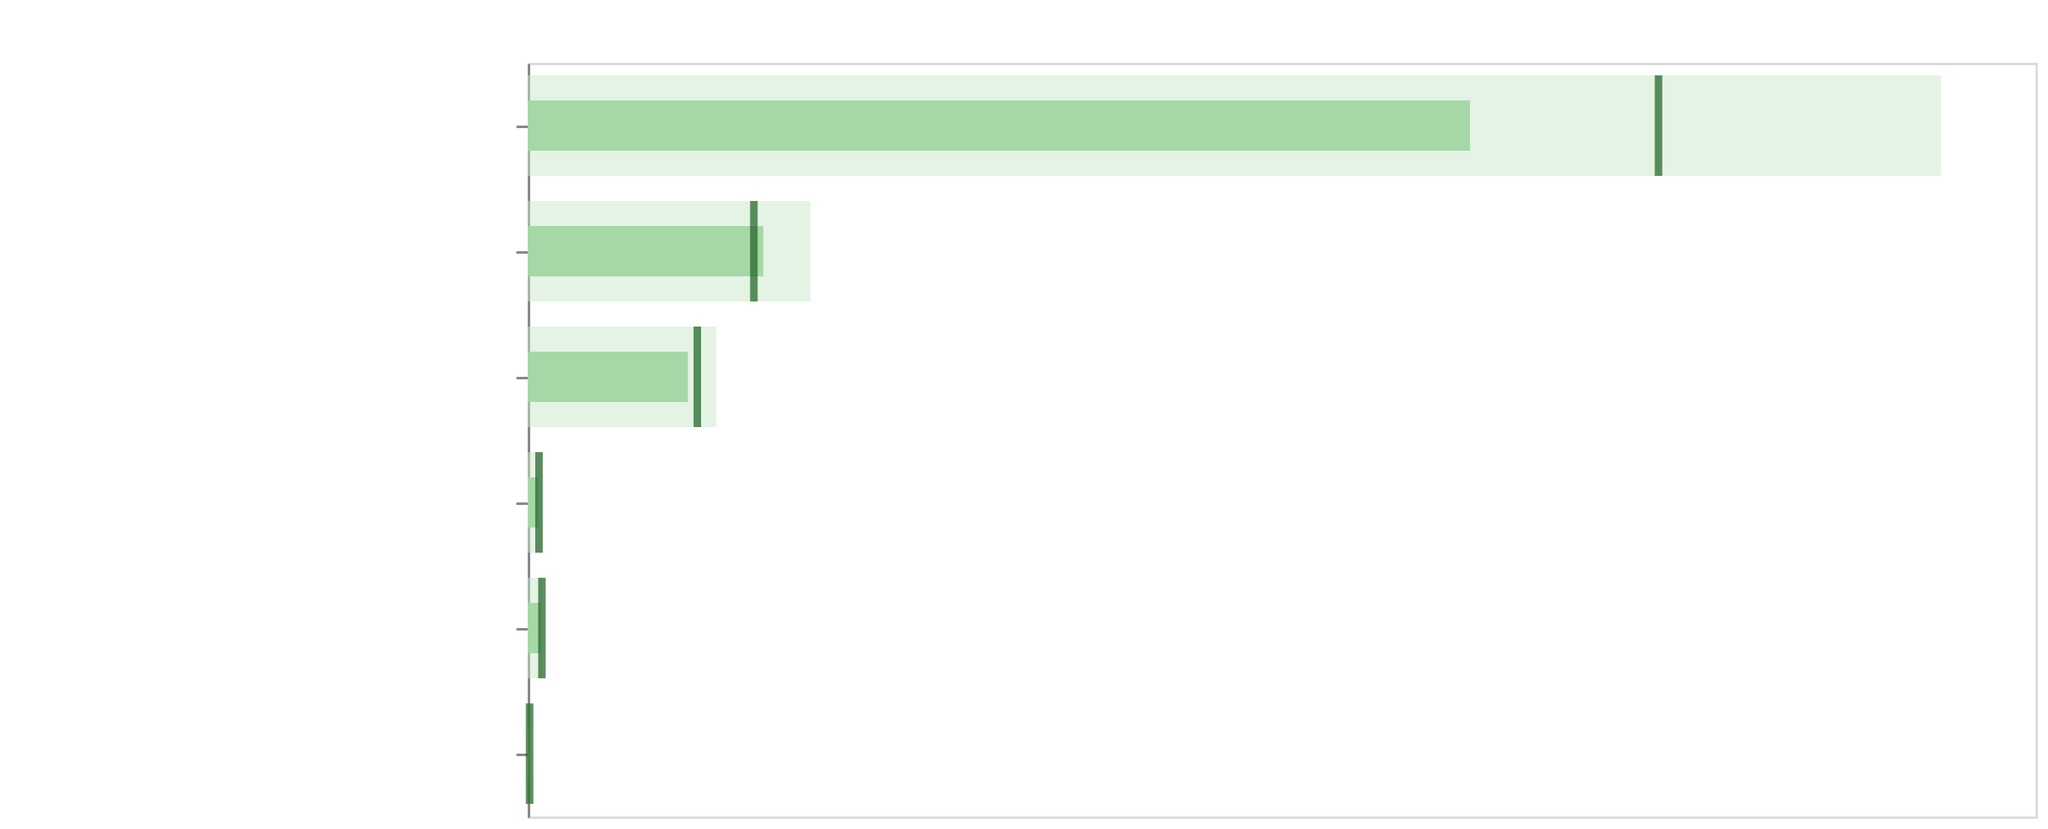What's the title of the chart? The title is written at the top of the figure. It reads "Environmental Sustainability Progress in Gaming Communities".
Answer: Environmental Sustainability Progress in Gaming Communities How many categories are there in the figure? Count the number of unique category names on the y-axis. There are six categories listed: Renewable Energy Usage (%), E-waste Recycling (tons), Carbon Offset (tons CO2), Eco-friendly Merch Sales ($K), Green Server Adoption (%), and Sustainability Awareness Events.
Answer: 6 Which category has the highest target value? Compare the target values across all categories. The highest target value is found in the Carbon Offset (tons CO2) category with a target value of 7500.
Answer: Carbon Offset (tons CO2) Is the actual value for Renewable Energy Usage (%) above or below its benchmark? Compare the actual value of 68 with the benchmark value of 75 for Renewable Energy Usage (%). Since 68 is less than 75, it is below the benchmark.
Answer: Below What is the difference between the target and actual values for E-waste Recycling (tons)? Subtract the actual value of 1250 from the target value of 1500 for E-waste Recycling (tons). The difference is 1500 - 1250 = 250.
Answer: 250 Which category shows the biggest shortfall from its target? Calculate the shortfall by subtracting actual from target values for each category and identify the maximum. Carbon Offset (tons CO2) has the largest shortfall: 7500 - 5000 = 2500.
Answer: Carbon Offset (tons CO2) How does the actual value for Green Server Adoption (%) compare to its target? Compare the actual value of 55 with the target value of 70 for Green Server Adoption (%). Since 55 is less than 70, it is below the target.
Answer: Below the target Are there any categories where the actual value exceeds the benchmark? Compare the actual value against the benchmark for all categories. Renewable Energy Usage (%): 68 < 75, E-waste Recycling (tons): 1250 > 1200, Carbon Offset (tons CO2): 5000 < 6000, Eco-friendly Merch Sales ($K): 850 < 900, Green Server Adoption (%): 55 < 60, Sustainability Awareness Events: 12 > 10. The categories E-waste Recycling (tons) and Sustainability Awareness Events show that actual exceeds the benchmark.
Answer: E-waste Recycling (tons) and Sustainability Awareness Events How many categories have actual values that are above both their respective benchmarks and target values? Determine if any actual values exceed both their benchmarks and targets. For all categories: Renewable Energy Usage (%): 68 < 75 and 80, E-waste Recycling (tons): 1250 < 1500, Carbon Offset (tons CO2): 5000 < 7500 and 6000, Eco-friendly Merch Sales ($K): 850 < 1000 and 900, Green Server Adoption (%): 55 < 70 and 60, Sustainability Awareness Events: 12 < 15. None of the actual values exceed both their benchmarks and targets.
Answer: None 